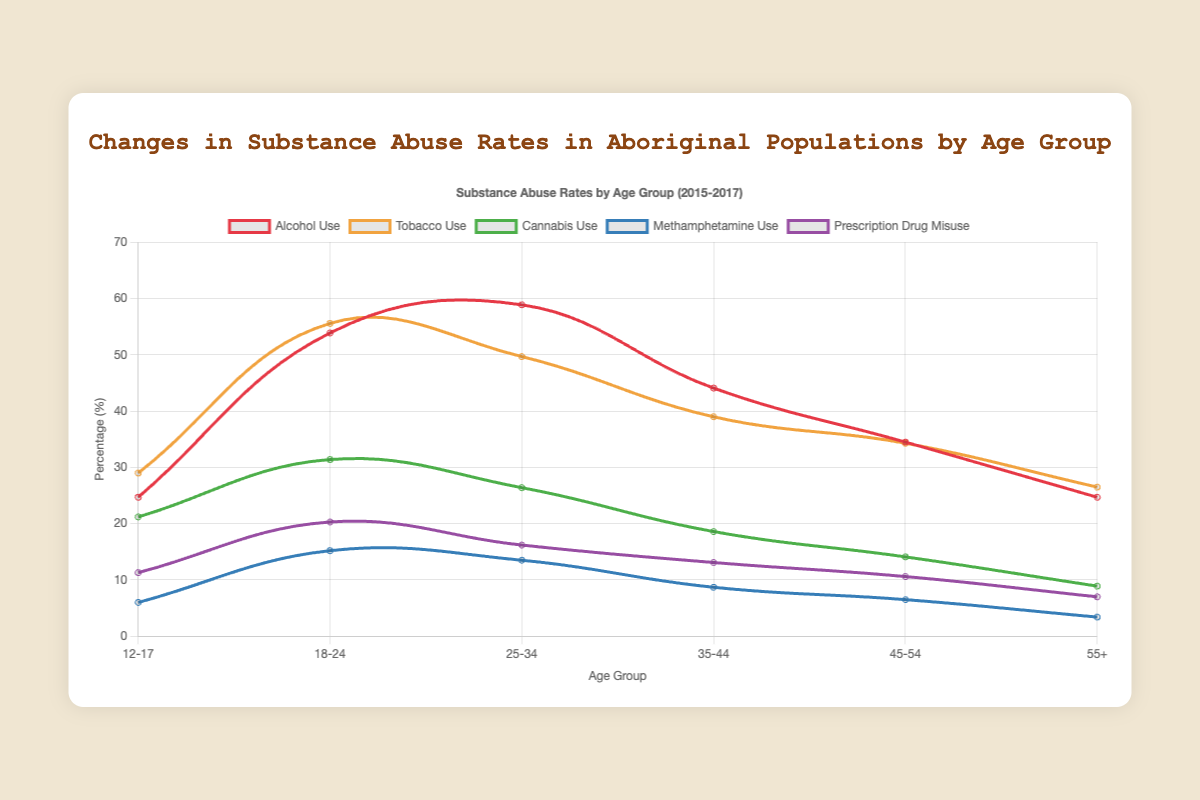Which age group has the highest tobacco use in 2015? To find the highest tobacco use in 2015, we look at the line that represents tobacco use and check the value for each age group in 2015. The 18-24 age group has the highest value at 57.0%.
Answer: 18-24 Which age group shows the most significant decrease in alcohol use from 2015 to 2017? We compare the alcohol use values for all the age groups between 2015 and 2017. The age group 18-24 shows the most significant decrease from 55.4% in 2015 to 52.7% in 2017, a difference of 2.7%.
Answer: 18-24 What is the average methamphetamine use for the 25-34 age group from 2015 to 2017? To find the average methamphetamine use, sum the values for 2015 (12.1%), 2016 (13.5%), and 2017 (12.9%) and then divide by 3. The sum is 12.1 + 13.5 + 12.9 = 38.5%, and the average is 38.5 / 3 ≈ 12.83%.
Answer: 12.83% Do the older age groups (45-54 and 55+) show higher or lower prescription drug misuse compared to the youngest age group (12-17) in 2017? We compare the prescription drug misuse values for 2017. For 12-17, it is 10.9%, for 45-54, it is 10.1%, and for 55+, it is 6.5%. Both older age groups have lower prescription drug misuse rates compared to the youngest age group.
Answer: Lower Which substance shows consistent decrease across all age groups from 2015 to 2017? We need to examine the trends for all substances across all age groups from 2015 to 2017. Alcohol use shows a consistent decrease across all age groups in this period.
Answer: Alcohol use For the 35-44 age group, how does the cannabis use in 2016 compare to the methamphetamine use in 2017? For the 35-44 age group in 2016, cannabis use is 18.6%. In 2017, methamphetamine use is 8.3%. Comparing these values shows cannabis use in 2016 is higher.
Answer: Higher What is the combined total percentage of alcohol and tobacco use for the 25-34 age group in 2017? To find the combined total percentage, add the alcohol use (57.5%) and tobacco use (47.9%) for the 25-34 age group in 2017. The total is 57.5 + 47.9 = 105.4%.
Answer: 105.4% Which age group experienced the highest increase in cannabis use between 2015 and 2016? We need to calculate the difference in cannabis use between 2015 and 2016 for all age groups. The 12-17 age group experienced an increase from 20.0% to 21.2%, which is the highest at 1.2%.
Answer: 12-17 Between 12-17 and 55+ age groups, which had a higher rate of methamphetamine use in 2016? Looking at the methamphetamine use values for 2016, the 12-17 age group has 6.0% and the 55+ age group has 3.4%. The 12-17 age group has a higher rate.
Answer: 12-17 